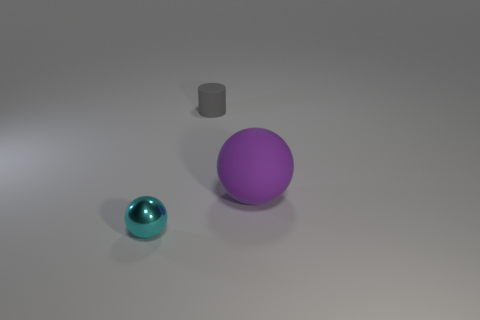What is the size of the thing that is the same material as the cylinder?
Your answer should be compact. Large. There is a rubber thing to the left of the rubber sphere; what is its shape?
Ensure brevity in your answer.  Cylinder. What is the size of the purple object that is the same shape as the small cyan object?
Give a very brief answer. Large. There is a object that is to the right of the tiny object that is behind the small cyan shiny thing; what number of purple things are in front of it?
Keep it short and to the point. 0. Are there an equal number of tiny things that are behind the large purple ball and small cyan shiny things?
Provide a succinct answer. Yes. What number of cylinders are tiny objects or shiny things?
Give a very brief answer. 1. Are there the same number of cyan metallic spheres that are right of the gray cylinder and large purple spheres to the right of the tiny sphere?
Ensure brevity in your answer.  No. What is the color of the big matte ball?
Offer a terse response. Purple. What number of objects are matte things that are to the left of the purple matte object or tiny cyan objects?
Ensure brevity in your answer.  2. There is a matte object that is left of the rubber ball; is it the same size as the ball that is behind the tiny metal ball?
Offer a terse response. No. 